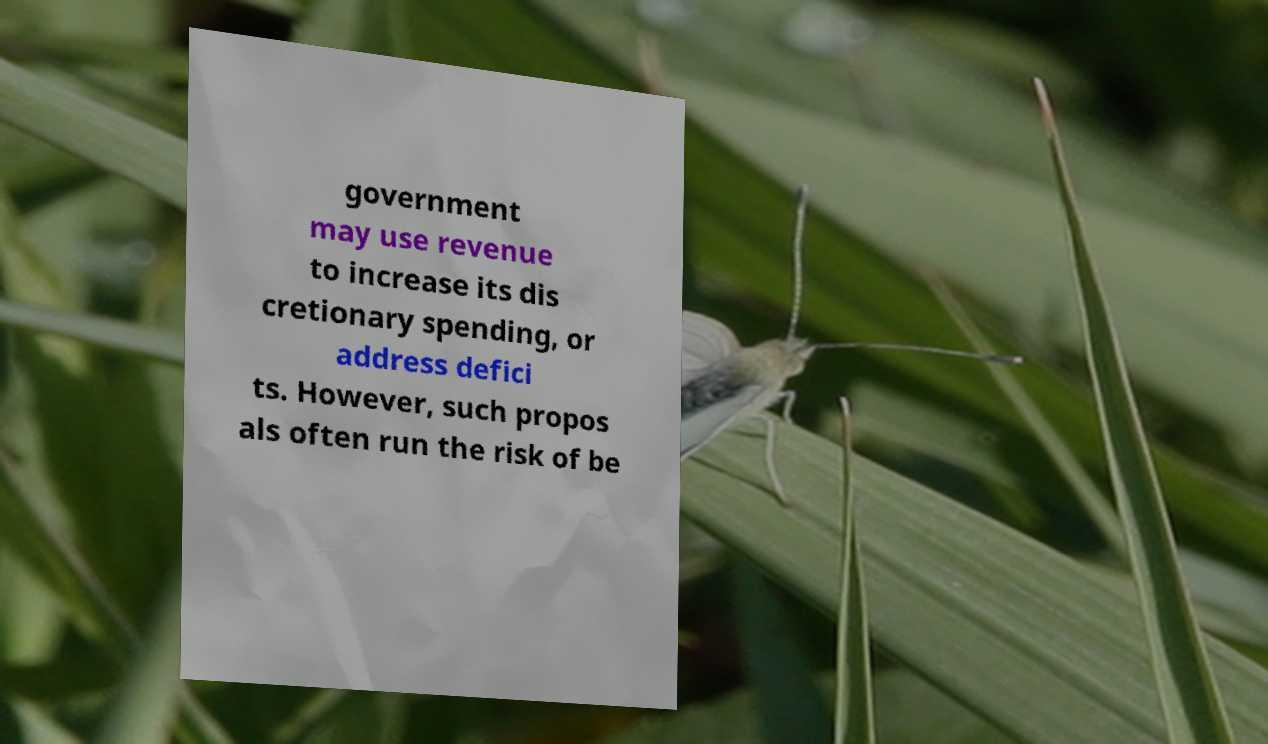There's text embedded in this image that I need extracted. Can you transcribe it verbatim? government may use revenue to increase its dis cretionary spending, or address defici ts. However, such propos als often run the risk of be 